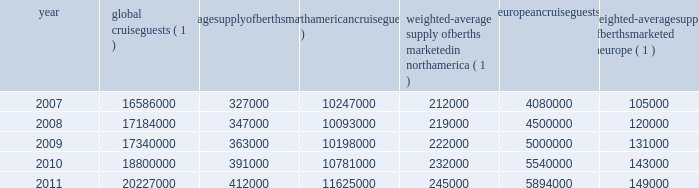Part i berths at the end of 2011 .
There are approximately 10 ships with an estimated 34000 berths that are expected to be placed in service in the north american cruise market between 2012 and 2016 .
Europe in europe , cruising represents a smaller but growing sector of the vacation industry .
It has experienced a compound annual growth rate in cruise guests of approximately 9.6% ( 9.6 % ) from 2007 to 2011 and we believe this market has significant continued growth poten- tial .
We estimate that europe was served by 104 ships with approximately 100000 berths at the beginning of 2007 and by 121 ships with approximately 155000 berths at the end of 2011 .
There are approximately 10 ships with an estimated 28000 berths that are expected to be placed in service in the european cruise market between 2012 and 2016 .
The table details the growth in the global , north american and european cruise markets in terms of cruise guests and estimated weighted-average berths over the past five years : global cruise guests ( 1 ) weighted-average supply of berths marketed globally ( 1 ) north american cruise guests ( 2 ) weighted-average supply of berths marketed in north america ( 1 ) european cruise guests ( 3 ) weighted-average supply of berths marketed in europe ( 1 ) .
( 1 ) source : our estimates of the number of global cruise guests , and the weighted-average supply of berths marketed globally , in north america and europe are based on a combination of data that we obtain from various publicly available cruise industry trade information sources including seatrade insider and cruise line international association .
In addition , our estimates incorporate our own statistical analysis utilizing the same publicly available cruise industry data as a base .
( 2 ) source : cruise line international association based on cruise guests carried for at least two consecutive nights for years 2007 through 2010 .
Year 2011 amounts represent our estimates ( see number 1 above ) .
( 3 ) source : european cruise council for years 2007 through 2010 .
Year 2011 amounts represent our estimates ( see number 1 above ) .
Other markets in addition to expected industry growth in north america and europe as discussed above , we expect the asia/pacific region to demonstrate an even higher growth rate in the near term , although it will continue to represent a relatively small sector compared to north america and europe .
We compete with a number of cruise lines ; however , our principal competitors are carnival corporation & plc , which owns , among others , aida cruises , carnival cruise lines , costa cruises , cunard line , holland america line , iberocruceros , p&o cruises and princess cruises ; disney cruise line ; msc cruises ; norwegian cruise line and oceania cruises .
Cruise lines compete with other vacation alternatives such as land-based resort hotels and sightseeing destinations for consum- ers 2019 leisure time .
Demand for such activities is influ- enced by political and general economic conditions .
Companies within the vacation market are dependent on consumer discretionary spending .
Operating strategies our principal operating strategies are to : and employees and protect the environment in which our vessels and organization operate , to better serve our global guest base and grow our business , order to enhance our revenues while continuing to expand and diversify our guest mix through interna- tional guest sourcing , and ensure adequate cash and liquidity , with the overall goal of maximizing our return on invested capital and long-term shareholder value , our brands throughout the world , revitalization of existing ships and the transfer of key innovations across each brand , while expanding our fleet with the new state-of-the-art cruise ships recently delivered and on order , by deploying them into those markets and itineraries that provide opportunities to optimize returns , while continuing our focus on existing key markets , support ongoing operations and initiatives , and the principal industry distribution channel , while enhancing our consumer outreach programs. .
What was the total percentage increase from 2007 to 2011 in the number of berths? 
Computations: (((155000 - 100000) / 100000) * 100)
Answer: 55.0. 